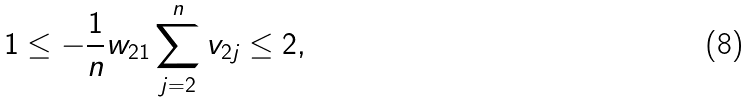Convert formula to latex. <formula><loc_0><loc_0><loc_500><loc_500>1 \leq - \frac { 1 } { n } w _ { 2 1 } \sum _ { j = 2 } ^ { n } v _ { 2 j } \leq 2 ,</formula> 